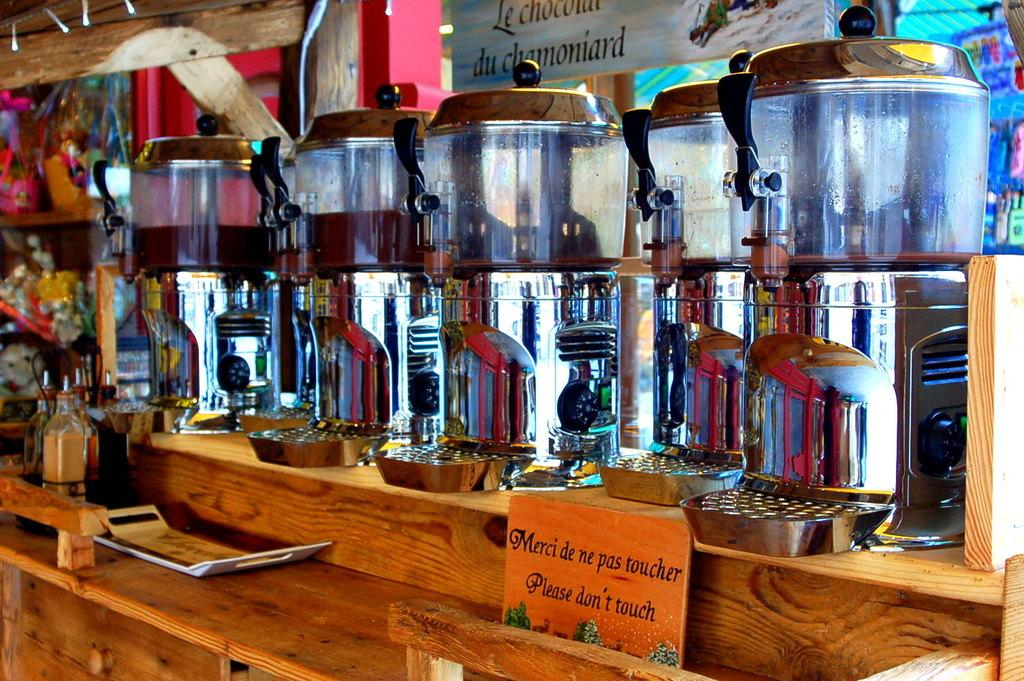<image>
Create a compact narrative representing the image presented. An orange sign in front of silver pots reads "please don't touch." 